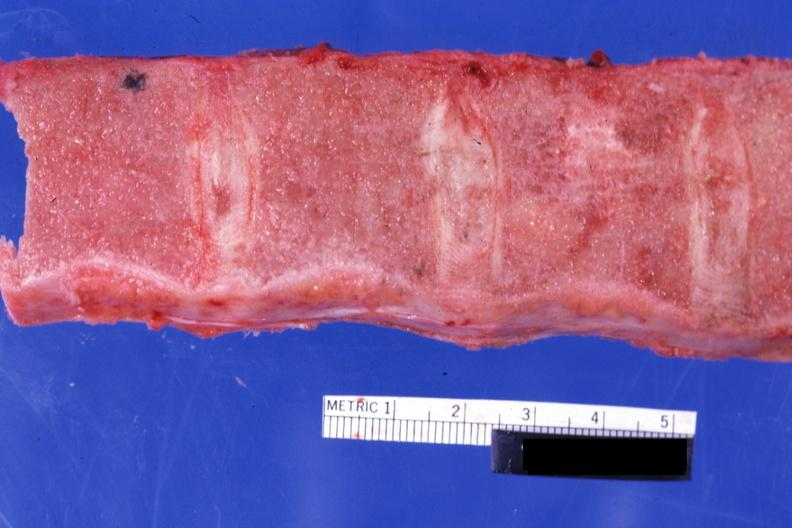what is present?
Answer the question using a single word or phrase. Hematologic 